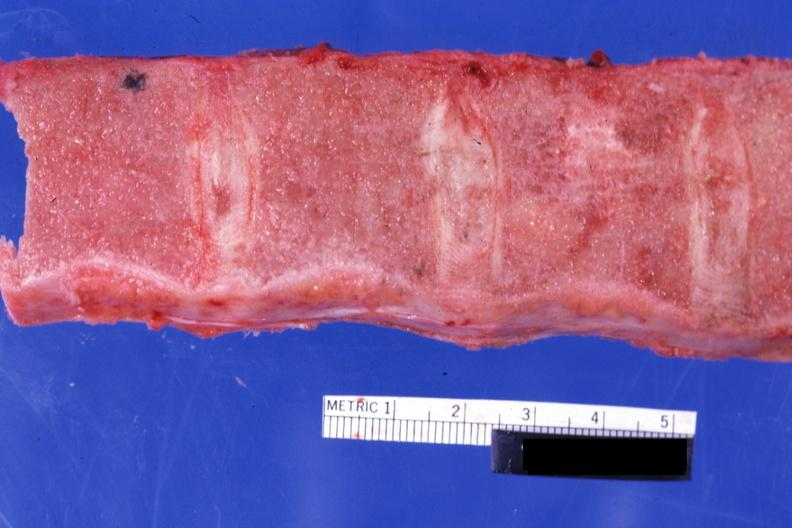what is present?
Answer the question using a single word or phrase. Hematologic 